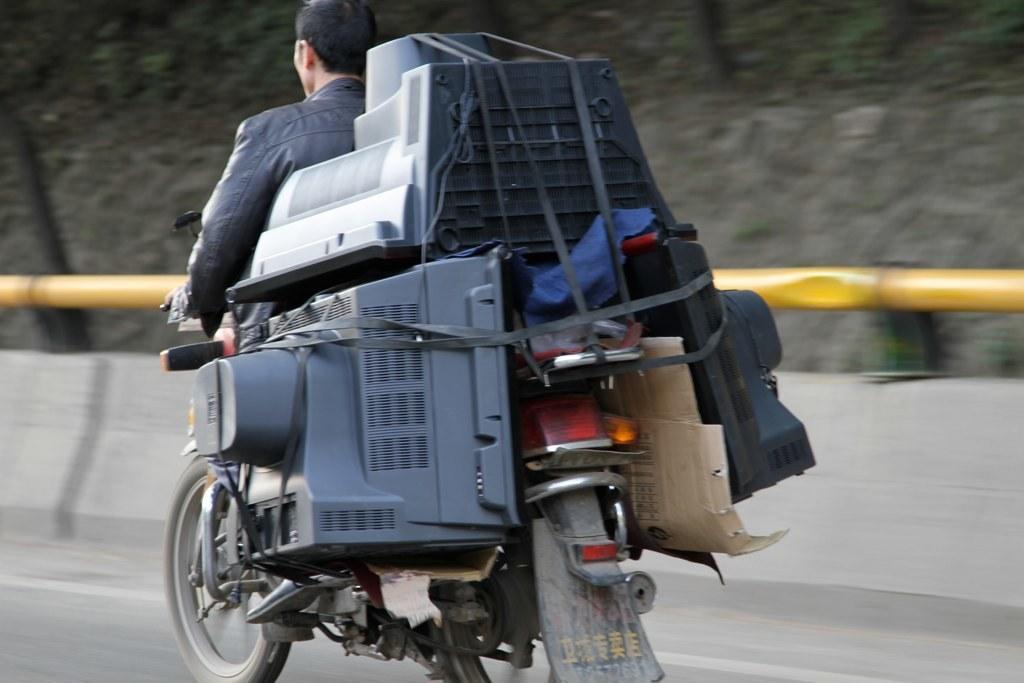Please provide a concise description of this image. In this image there is a person riding a motor vehicle on the road, there are few TV´s and a cardboard sheet attached to the wall, there is a stone. 